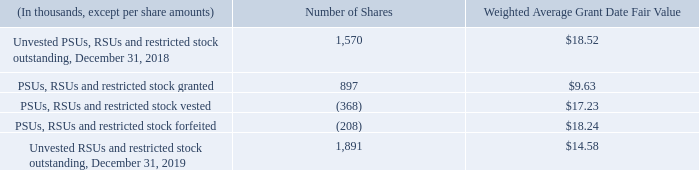PSUs, RSUs and restricted stock
Under the 2015 Plan, awards other than stock options, including PSUs, RSUs and restricted stock, may be granted to certain employees and officers.
Under our market-based PSU program, the number of shares of common stock earned by a recipient is subject to a market condition based on ADTRAN’s relative total shareholder return against all companies in the NASDAQ Telecommunications Index at the end of a three-year performance period. Depending on the relative total shareholder return over the performance period, the recipient may earn from 0% to 150% of the shares underlying the PSUs, with the shares earned distributed upon the vesting. The fair value of the award is based on the market price of our common stock on the date of grant, adjusted for the expected outcome of the impact of market conditions using a Monte Carlo Simulation valuation method. A portion of the granted PSUs vests and the underlying shares become deliverable upon the death or disability of the recipient or upon a change of control of ADTRAN, as defined by the 2015 Plan. The recipients of the PSUs receive dividend credits based on the shares of common stock underlying the PSUs. The dividend credits vest and are earned in the same manner as the PSUs and are paid in cash upon the issuance of common stock for the PSUs.
During the first quarter of 2017, the Compensation Committee of the Board of Directors approved a one-time PSU grant of 0.5 million shares that contained performance conditions and would have vested at the end of a three-year period if such performance conditions were met. The fair value of these performance-based PSU awards was equal to the closing price of our stock on the date of grant. These awards were forfeited during the first quarter of 2020 as the performance conditions were not achieved.
The fair value of RSUs and restricted stock is equal to the closing price of our stock on the business day immediately preceding the grant date. RSUs and restricted stock vest ratably over four-year and one-year periods, respectively.
We will continue to assess the assumptions and methodologies used to calculate the estimated fair value of stock-based compensation. If circumstances change, and additional data becomes available over time, we may change our assumptions and methodologies, which may materially impact our fair value determination.
The following table is a summary of our PSUs, RSUs and restricted stock outstanding as of December 31, 2018 and 2019 and the changes that occurred during 2019:
What was the number of shares of PSUs, RSUs and restricted stock granted 
Answer scale should be: thousand. 897. What was the number of Unvested RSUs and restricted stock outstanding in 2018?
Answer scale should be: thousand. 1,570. What is the fair value of RSUs and restricted stock equal to? The closing price of our stock on the business day immediately preceding the grant date. What was the change in Unvested RSUs and restricted stock outstanding between 2018 and 2019?
Answer scale should be: thousand. 1,891-1,570
Answer: 321. What was the difference between the weighted average grant date fair value of PSUs, RSUs and restricted stock that are granted as compared to those that are vested? $17.23-$9.63
Answer: 7.6. What was the Weighted Average Grant Date Fair Value of unvested stocks in 2018 as a ratio of the fair value in 2019? $18.52/$14.58
Answer: 1.27. 